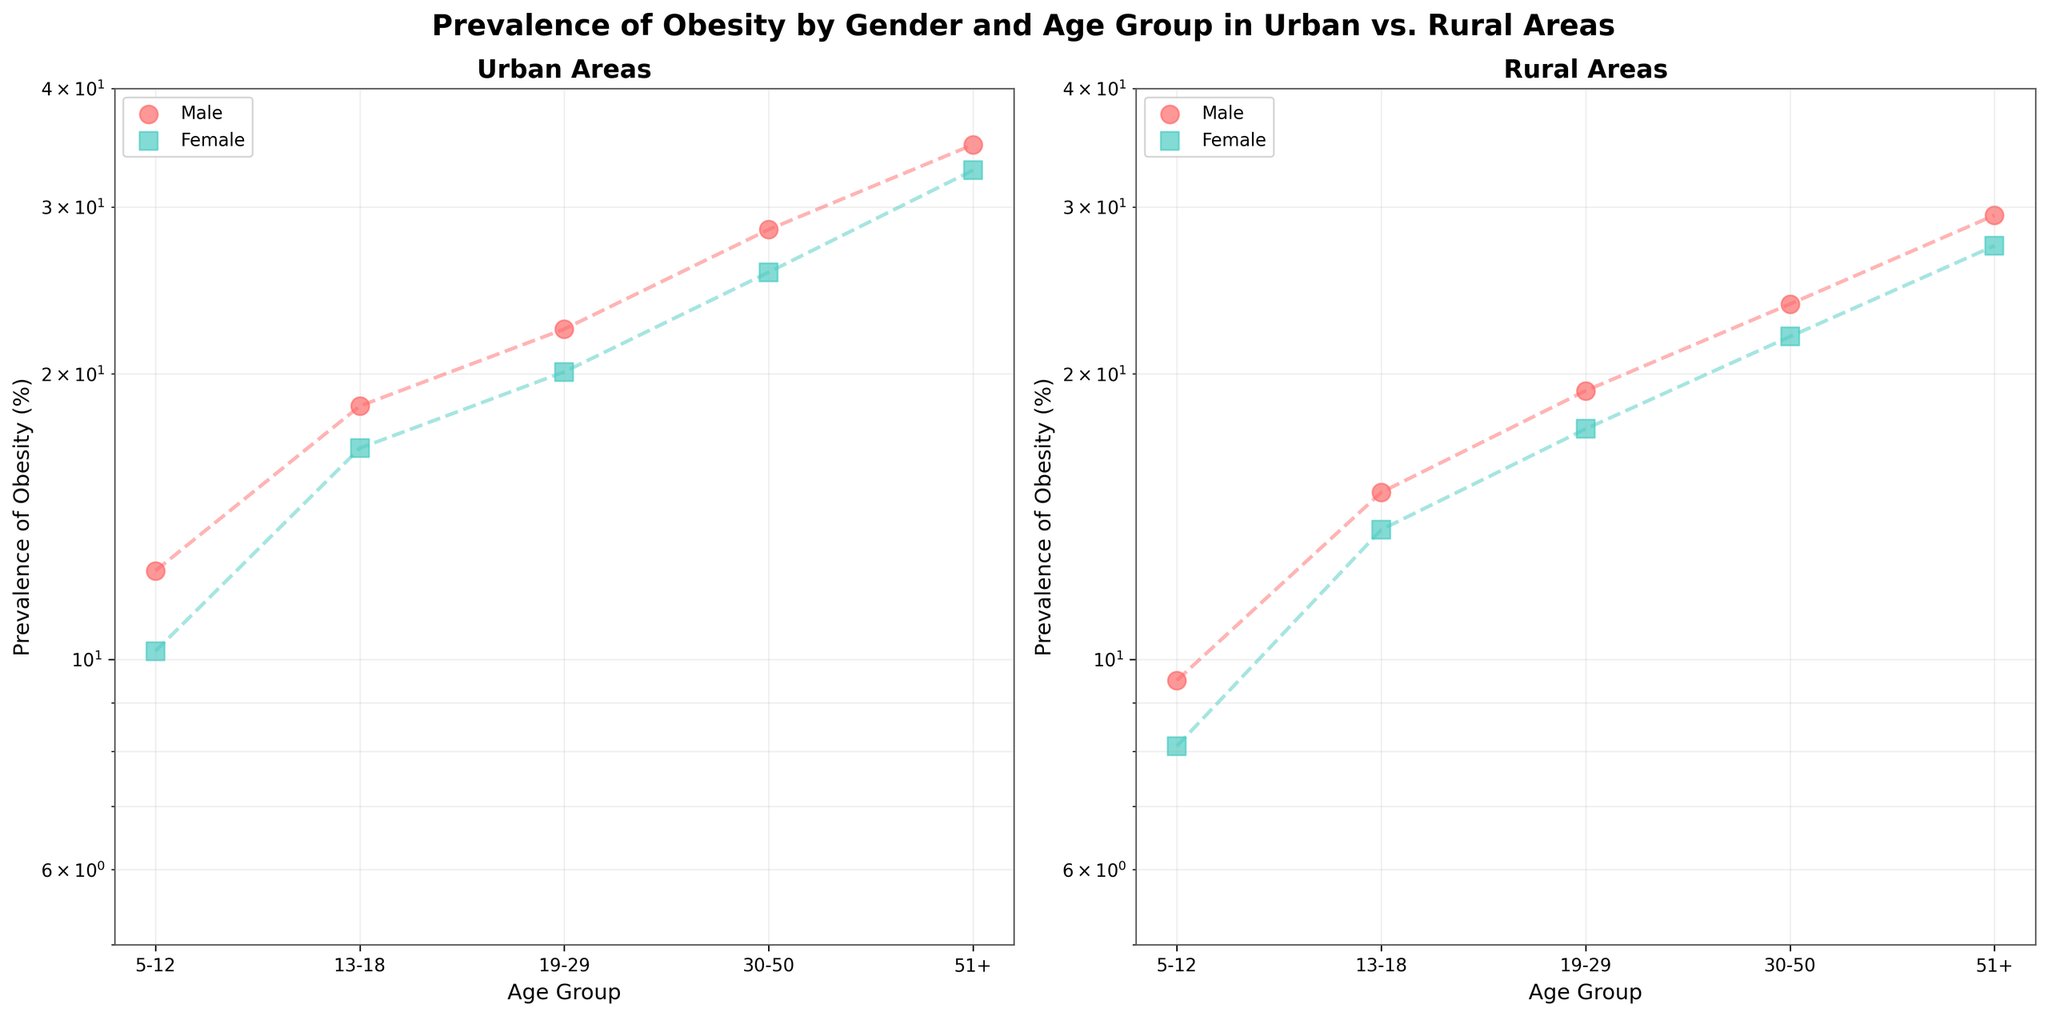Which area has a higher prevalence of obesity in the 19-29 age group, Urban or Rural? By observing the plot for the 19-29 age group, the prevalence of obesity for Urban males is 22.3% and females is 20.1%, while Rural males are at 19.2% and females at 17.5%. Urban percentages are higher.
Answer: Urban What is the title of the figure? The title is placed at the top center of the figure area. It clearly states the content and the scope of the figure.
Answer: Prevalence of Obesity by Gender and Age Group in Urban vs. Rural Areas For which gender is the increase in obesity prevalence most significant between the 30-50 and 51+ age groups in Urban areas? Comparing the 30-50 and 51+ age groups in Urban areas, the obesity prevalence increases from 28.4% to 34.9% for males and from 25.6% to 32.8% for females. The increase is larger for males (6.5% compared to 7.2%).
Answer: Male How does the obesity prevalence in rural areas compare between the 5-12 and 13-18 age groups for females? In Rural areas, the prevalence of obesity for females is 8.1% in the 5-12 age group and 13.7% in the 13-18 age group, showing an increase.
Answer: It increases Which area has a higher maximum prevalence of obesity across all age groups and genders? By examining the highest data points shown in the plots, the highest prevalence is 34.9% for Urban males in the 51+ age group, while in Rural areas it is 29.4% for males in the 51+ age group. Urban areas have a higher maximum.
Answer: Urban What is the color used for the data points of Urban females? The plot uses a specific color code for different genders and areas. Observing the color used helps in identifying categories visually.
Answer: Red Is the prevalence of obesity scale in the figure linear or logarithmic? The y-axis of the figure is designed on a logarithmic scale, which is indicated in the axis type, providing a clear view of the data range.
Answer: Logarithmic Which age group in Rural areas shows the minimum prevalence of obesity for males? By examining the data points marked for the Rural males in various age groups, the 5-12 age group shows the minimum prevalence of 9.5%.
Answer: 5-12 